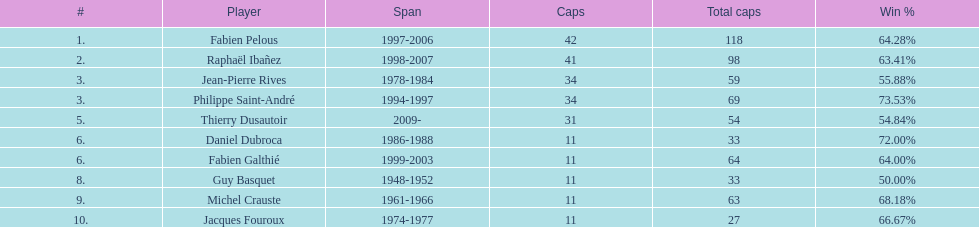How many years did fabien pelous hold the captain position in the french national rugby team? 9 years. 